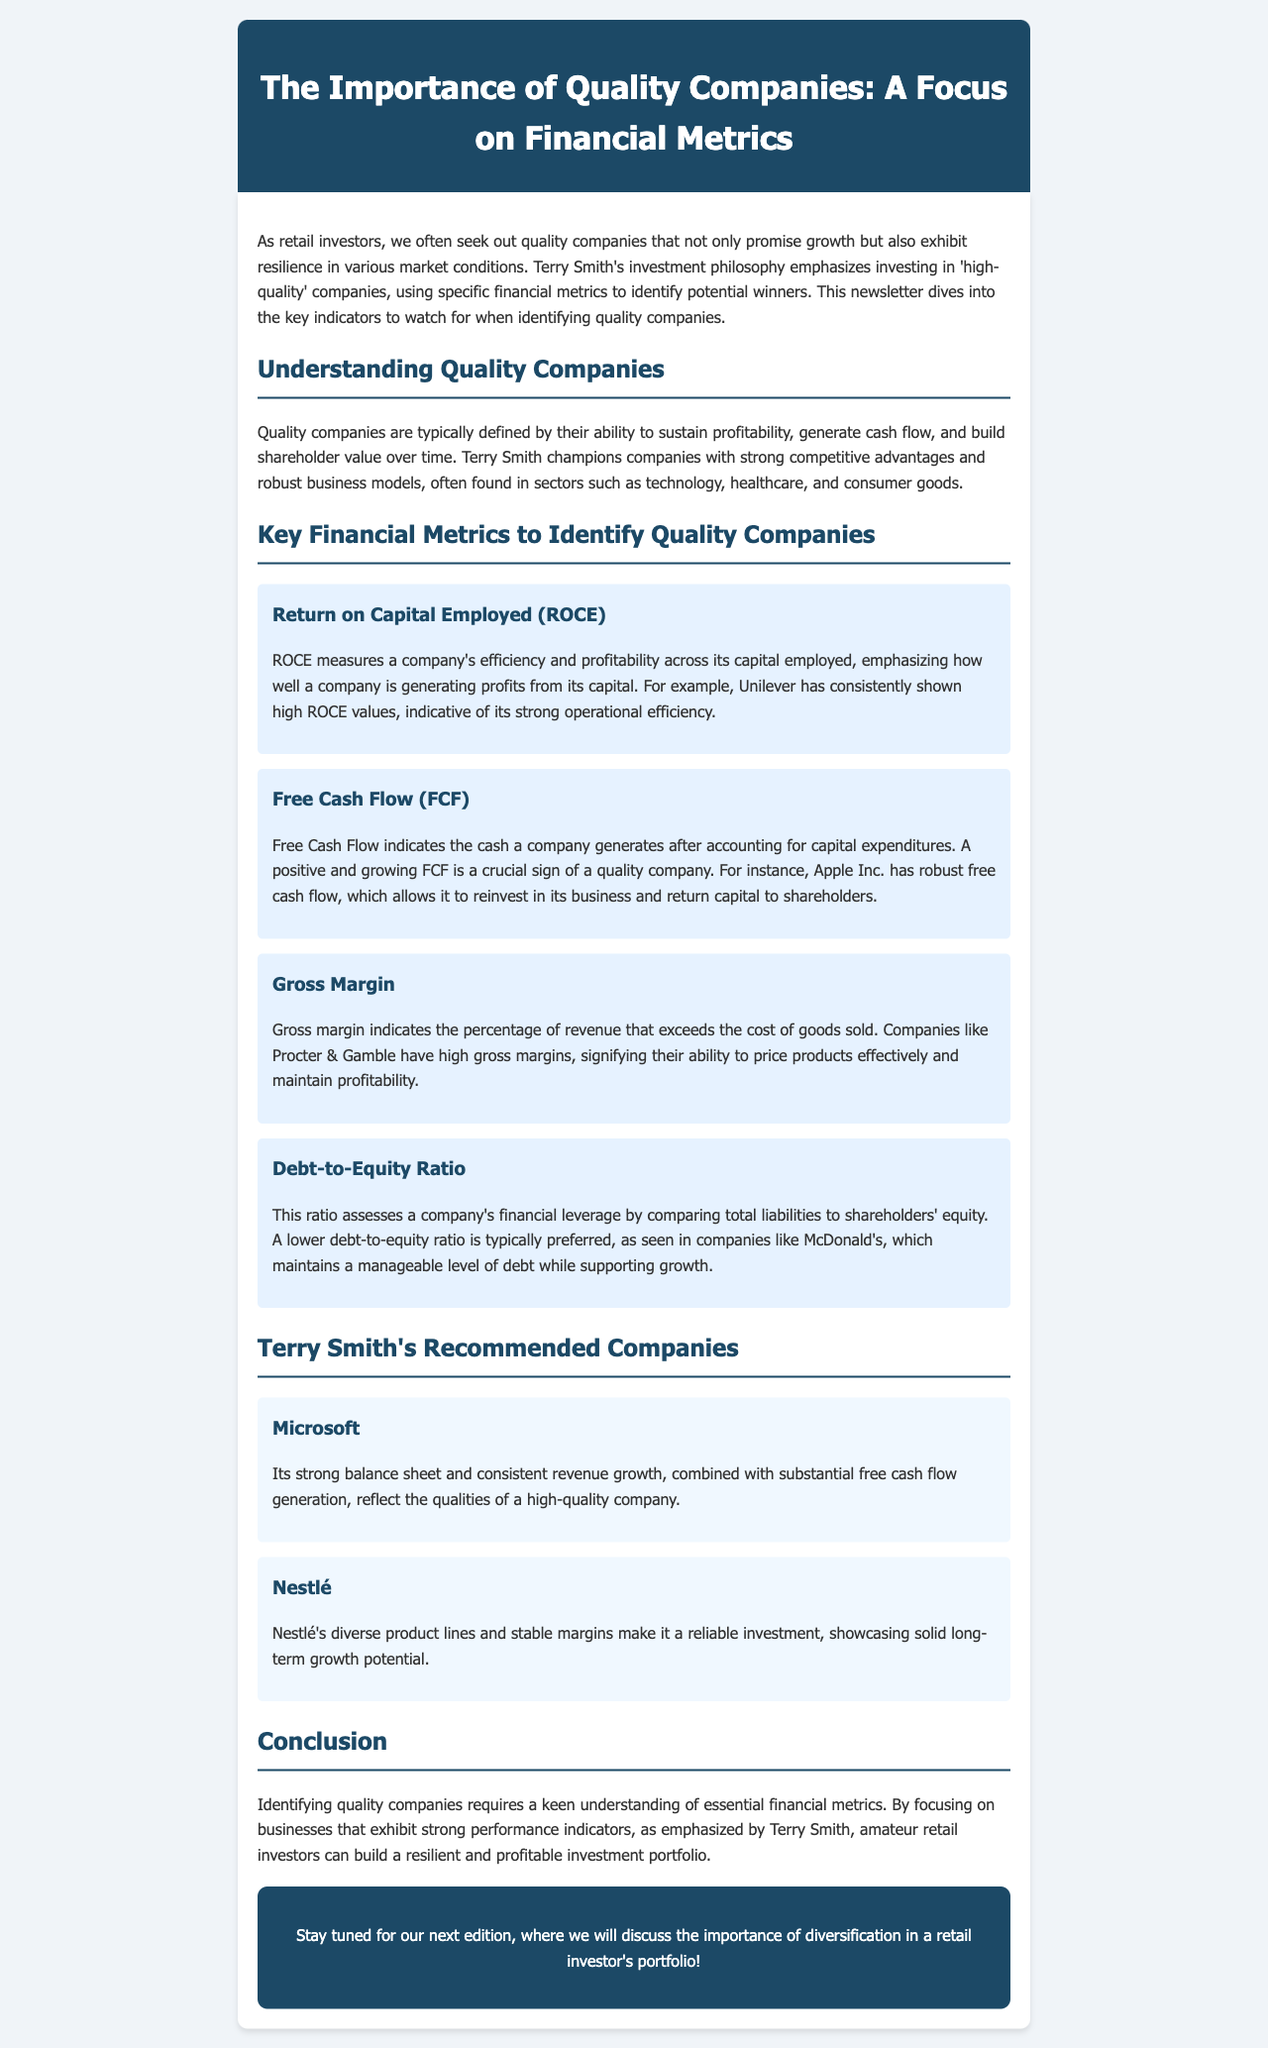what is the focus of the newsletter? The newsletter emphasizes the importance of quality companies and focuses on financial metrics that can help identify them.
Answer: quality companies and financial metrics who champions investing in high-quality companies? Terry Smith is the individual known for championing the investment in high-quality companies.
Answer: Terry Smith which financial metric indicates cash generated after capital expenditures? Free Cash Flow (FCF) is the financial metric that indicates the cash generated after accounting for capital expenditures.
Answer: Free Cash Flow (FCF) what is the preferred level of debt-to-equity ratio as mentioned? A lower debt-to-equity ratio is typically preferred when assessing quality companies.
Answer: lower which company is mentioned as an example of strong operational efficiency through ROCE? Unilever is highlighted as an example of a company with strong operational efficiency through high ROCE values.
Answer: Unilever what does a high gross margin signify? A high gross margin signifies a company's ability to price products effectively and maintain profitability.
Answer: pricing products effectively what does the newsletter suggest is a reliable investment? The newsletter suggests that Nestlé is a reliable investment due to its diverse product lines and stable margins.
Answer: Nestlé which two companies are recommended by Terry Smith in the newsletter? Microsoft and Nestlé are specifically mentioned as recommended companies by Terry Smith.
Answer: Microsoft and Nestlé what is the next topic to be discussed in the following edition? The next edition will discuss the importance of diversification in a retail investor's portfolio.
Answer: diversification in a retail investor's portfolio 